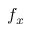Convert formula to latex. <formula><loc_0><loc_0><loc_500><loc_500>f _ { x }</formula> 